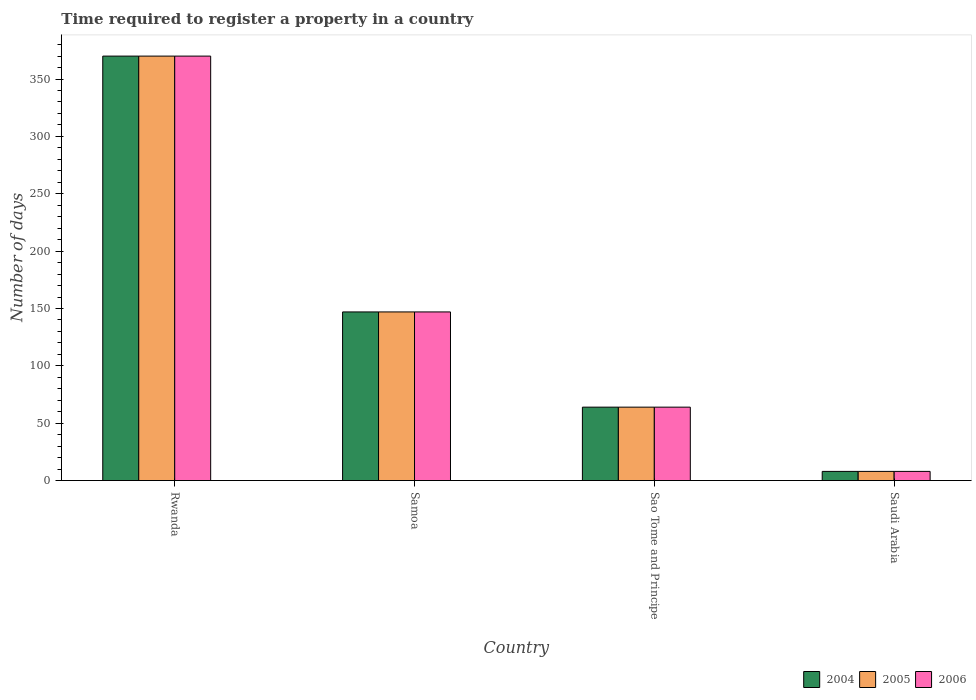How many groups of bars are there?
Offer a terse response. 4. How many bars are there on the 2nd tick from the left?
Your response must be concise. 3. What is the label of the 3rd group of bars from the left?
Provide a succinct answer. Sao Tome and Principe. What is the number of days required to register a property in 2004 in Rwanda?
Your response must be concise. 370. Across all countries, what is the maximum number of days required to register a property in 2004?
Offer a terse response. 370. Across all countries, what is the minimum number of days required to register a property in 2006?
Keep it short and to the point. 8. In which country was the number of days required to register a property in 2006 maximum?
Provide a short and direct response. Rwanda. In which country was the number of days required to register a property in 2006 minimum?
Provide a succinct answer. Saudi Arabia. What is the total number of days required to register a property in 2005 in the graph?
Offer a terse response. 589. What is the difference between the number of days required to register a property in 2005 in Samoa and that in Sao Tome and Principe?
Provide a short and direct response. 83. What is the difference between the number of days required to register a property in 2004 in Saudi Arabia and the number of days required to register a property in 2005 in Samoa?
Make the answer very short. -139. What is the average number of days required to register a property in 2005 per country?
Your answer should be very brief. 147.25. In how many countries, is the number of days required to register a property in 2005 greater than 60 days?
Provide a succinct answer. 3. What is the ratio of the number of days required to register a property in 2005 in Rwanda to that in Samoa?
Your answer should be very brief. 2.52. Is the number of days required to register a property in 2006 in Sao Tome and Principe less than that in Saudi Arabia?
Your response must be concise. No. What is the difference between the highest and the second highest number of days required to register a property in 2004?
Your answer should be very brief. -306. What is the difference between the highest and the lowest number of days required to register a property in 2004?
Offer a very short reply. 362. What does the 1st bar from the left in Sao Tome and Principe represents?
Make the answer very short. 2004. What does the 3rd bar from the right in Samoa represents?
Ensure brevity in your answer.  2004. Is it the case that in every country, the sum of the number of days required to register a property in 2005 and number of days required to register a property in 2004 is greater than the number of days required to register a property in 2006?
Provide a succinct answer. Yes. Are all the bars in the graph horizontal?
Your response must be concise. No. How many countries are there in the graph?
Your answer should be very brief. 4. What is the difference between two consecutive major ticks on the Y-axis?
Provide a succinct answer. 50. Are the values on the major ticks of Y-axis written in scientific E-notation?
Offer a very short reply. No. Where does the legend appear in the graph?
Provide a succinct answer. Bottom right. What is the title of the graph?
Offer a very short reply. Time required to register a property in a country. What is the label or title of the X-axis?
Provide a short and direct response. Country. What is the label or title of the Y-axis?
Ensure brevity in your answer.  Number of days. What is the Number of days of 2004 in Rwanda?
Provide a short and direct response. 370. What is the Number of days of 2005 in Rwanda?
Ensure brevity in your answer.  370. What is the Number of days in 2006 in Rwanda?
Your answer should be very brief. 370. What is the Number of days of 2004 in Samoa?
Ensure brevity in your answer.  147. What is the Number of days in 2005 in Samoa?
Ensure brevity in your answer.  147. What is the Number of days of 2006 in Samoa?
Offer a terse response. 147. What is the Number of days of 2005 in Sao Tome and Principe?
Your answer should be very brief. 64. What is the Number of days of 2004 in Saudi Arabia?
Give a very brief answer. 8. What is the Number of days in 2006 in Saudi Arabia?
Make the answer very short. 8. Across all countries, what is the maximum Number of days in 2004?
Make the answer very short. 370. Across all countries, what is the maximum Number of days in 2005?
Give a very brief answer. 370. Across all countries, what is the maximum Number of days in 2006?
Make the answer very short. 370. Across all countries, what is the minimum Number of days in 2005?
Your answer should be very brief. 8. Across all countries, what is the minimum Number of days of 2006?
Your response must be concise. 8. What is the total Number of days of 2004 in the graph?
Offer a very short reply. 589. What is the total Number of days of 2005 in the graph?
Your response must be concise. 589. What is the total Number of days in 2006 in the graph?
Your response must be concise. 589. What is the difference between the Number of days of 2004 in Rwanda and that in Samoa?
Offer a terse response. 223. What is the difference between the Number of days in 2005 in Rwanda and that in Samoa?
Keep it short and to the point. 223. What is the difference between the Number of days in 2006 in Rwanda and that in Samoa?
Make the answer very short. 223. What is the difference between the Number of days in 2004 in Rwanda and that in Sao Tome and Principe?
Ensure brevity in your answer.  306. What is the difference between the Number of days in 2005 in Rwanda and that in Sao Tome and Principe?
Offer a terse response. 306. What is the difference between the Number of days of 2006 in Rwanda and that in Sao Tome and Principe?
Your answer should be compact. 306. What is the difference between the Number of days of 2004 in Rwanda and that in Saudi Arabia?
Your answer should be compact. 362. What is the difference between the Number of days of 2005 in Rwanda and that in Saudi Arabia?
Provide a succinct answer. 362. What is the difference between the Number of days in 2006 in Rwanda and that in Saudi Arabia?
Provide a succinct answer. 362. What is the difference between the Number of days in 2004 in Samoa and that in Saudi Arabia?
Keep it short and to the point. 139. What is the difference between the Number of days in 2005 in Samoa and that in Saudi Arabia?
Your answer should be very brief. 139. What is the difference between the Number of days in 2006 in Samoa and that in Saudi Arabia?
Make the answer very short. 139. What is the difference between the Number of days in 2005 in Sao Tome and Principe and that in Saudi Arabia?
Your answer should be very brief. 56. What is the difference between the Number of days in 2004 in Rwanda and the Number of days in 2005 in Samoa?
Provide a succinct answer. 223. What is the difference between the Number of days of 2004 in Rwanda and the Number of days of 2006 in Samoa?
Ensure brevity in your answer.  223. What is the difference between the Number of days of 2005 in Rwanda and the Number of days of 2006 in Samoa?
Offer a terse response. 223. What is the difference between the Number of days of 2004 in Rwanda and the Number of days of 2005 in Sao Tome and Principe?
Offer a terse response. 306. What is the difference between the Number of days in 2004 in Rwanda and the Number of days in 2006 in Sao Tome and Principe?
Your response must be concise. 306. What is the difference between the Number of days in 2005 in Rwanda and the Number of days in 2006 in Sao Tome and Principe?
Your answer should be very brief. 306. What is the difference between the Number of days in 2004 in Rwanda and the Number of days in 2005 in Saudi Arabia?
Provide a short and direct response. 362. What is the difference between the Number of days of 2004 in Rwanda and the Number of days of 2006 in Saudi Arabia?
Your response must be concise. 362. What is the difference between the Number of days of 2005 in Rwanda and the Number of days of 2006 in Saudi Arabia?
Provide a succinct answer. 362. What is the difference between the Number of days of 2005 in Samoa and the Number of days of 2006 in Sao Tome and Principe?
Make the answer very short. 83. What is the difference between the Number of days in 2004 in Samoa and the Number of days in 2005 in Saudi Arabia?
Offer a terse response. 139. What is the difference between the Number of days of 2004 in Samoa and the Number of days of 2006 in Saudi Arabia?
Offer a very short reply. 139. What is the difference between the Number of days of 2005 in Samoa and the Number of days of 2006 in Saudi Arabia?
Give a very brief answer. 139. What is the difference between the Number of days of 2004 in Sao Tome and Principe and the Number of days of 2005 in Saudi Arabia?
Give a very brief answer. 56. What is the difference between the Number of days of 2004 in Sao Tome and Principe and the Number of days of 2006 in Saudi Arabia?
Provide a short and direct response. 56. What is the average Number of days of 2004 per country?
Your answer should be compact. 147.25. What is the average Number of days of 2005 per country?
Offer a terse response. 147.25. What is the average Number of days of 2006 per country?
Provide a short and direct response. 147.25. What is the difference between the Number of days of 2004 and Number of days of 2005 in Rwanda?
Provide a succinct answer. 0. What is the difference between the Number of days in 2004 and Number of days in 2006 in Rwanda?
Make the answer very short. 0. What is the difference between the Number of days of 2005 and Number of days of 2006 in Samoa?
Keep it short and to the point. 0. What is the difference between the Number of days in 2004 and Number of days in 2005 in Sao Tome and Principe?
Keep it short and to the point. 0. What is the difference between the Number of days in 2004 and Number of days in 2005 in Saudi Arabia?
Keep it short and to the point. 0. What is the difference between the Number of days in 2004 and Number of days in 2006 in Saudi Arabia?
Make the answer very short. 0. What is the ratio of the Number of days in 2004 in Rwanda to that in Samoa?
Offer a very short reply. 2.52. What is the ratio of the Number of days of 2005 in Rwanda to that in Samoa?
Offer a terse response. 2.52. What is the ratio of the Number of days of 2006 in Rwanda to that in Samoa?
Ensure brevity in your answer.  2.52. What is the ratio of the Number of days in 2004 in Rwanda to that in Sao Tome and Principe?
Your answer should be compact. 5.78. What is the ratio of the Number of days in 2005 in Rwanda to that in Sao Tome and Principe?
Make the answer very short. 5.78. What is the ratio of the Number of days in 2006 in Rwanda to that in Sao Tome and Principe?
Keep it short and to the point. 5.78. What is the ratio of the Number of days in 2004 in Rwanda to that in Saudi Arabia?
Your response must be concise. 46.25. What is the ratio of the Number of days in 2005 in Rwanda to that in Saudi Arabia?
Offer a very short reply. 46.25. What is the ratio of the Number of days of 2006 in Rwanda to that in Saudi Arabia?
Your answer should be very brief. 46.25. What is the ratio of the Number of days in 2004 in Samoa to that in Sao Tome and Principe?
Your response must be concise. 2.3. What is the ratio of the Number of days of 2005 in Samoa to that in Sao Tome and Principe?
Your response must be concise. 2.3. What is the ratio of the Number of days of 2006 in Samoa to that in Sao Tome and Principe?
Give a very brief answer. 2.3. What is the ratio of the Number of days of 2004 in Samoa to that in Saudi Arabia?
Give a very brief answer. 18.38. What is the ratio of the Number of days in 2005 in Samoa to that in Saudi Arabia?
Your answer should be compact. 18.38. What is the ratio of the Number of days in 2006 in Samoa to that in Saudi Arabia?
Your answer should be compact. 18.38. What is the ratio of the Number of days of 2004 in Sao Tome and Principe to that in Saudi Arabia?
Your response must be concise. 8. What is the ratio of the Number of days in 2006 in Sao Tome and Principe to that in Saudi Arabia?
Your answer should be very brief. 8. What is the difference between the highest and the second highest Number of days of 2004?
Give a very brief answer. 223. What is the difference between the highest and the second highest Number of days of 2005?
Offer a terse response. 223. What is the difference between the highest and the second highest Number of days of 2006?
Provide a short and direct response. 223. What is the difference between the highest and the lowest Number of days of 2004?
Ensure brevity in your answer.  362. What is the difference between the highest and the lowest Number of days of 2005?
Ensure brevity in your answer.  362. What is the difference between the highest and the lowest Number of days of 2006?
Your answer should be compact. 362. 